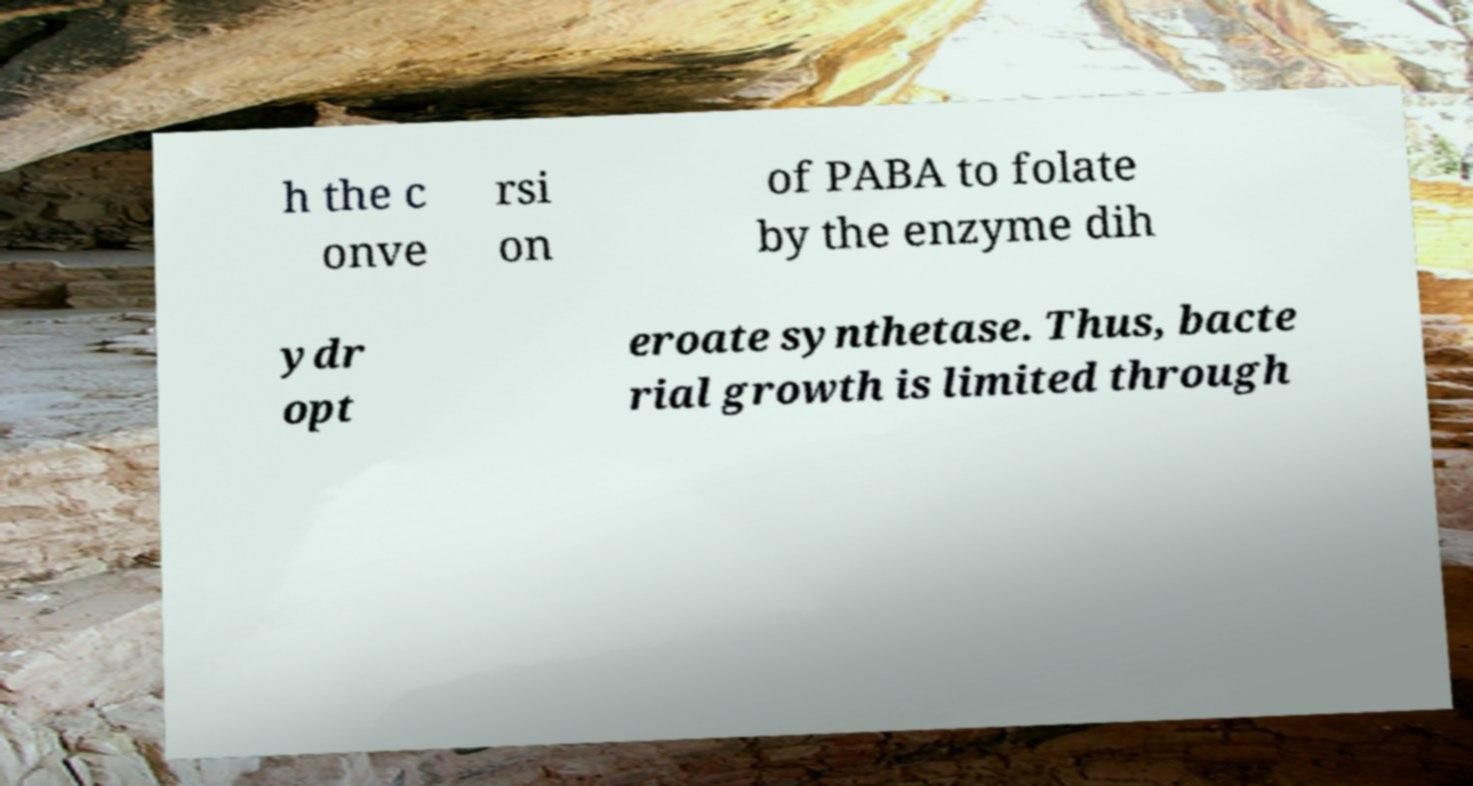Please read and relay the text visible in this image. What does it say? h the c onve rsi on of PABA to folate by the enzyme dih ydr opt eroate synthetase. Thus, bacte rial growth is limited through 